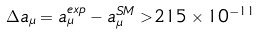Convert formula to latex. <formula><loc_0><loc_0><loc_500><loc_500>\Delta a _ { \mu } = a _ { \mu } ^ { e x p } - a _ { \mu } ^ { S M } > 2 1 5 \times 1 0 ^ { - 1 1 }</formula> 